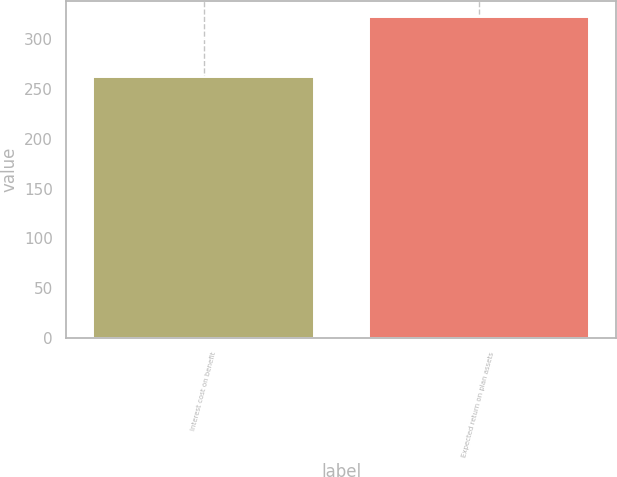Convert chart. <chart><loc_0><loc_0><loc_500><loc_500><bar_chart><fcel>Interest cost on benefit<fcel>Expected return on plan assets<nl><fcel>262<fcel>322<nl></chart> 